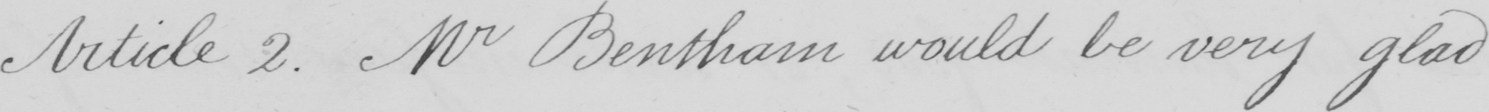What does this handwritten line say? Article 2 . Mr Bentham would be very glad 